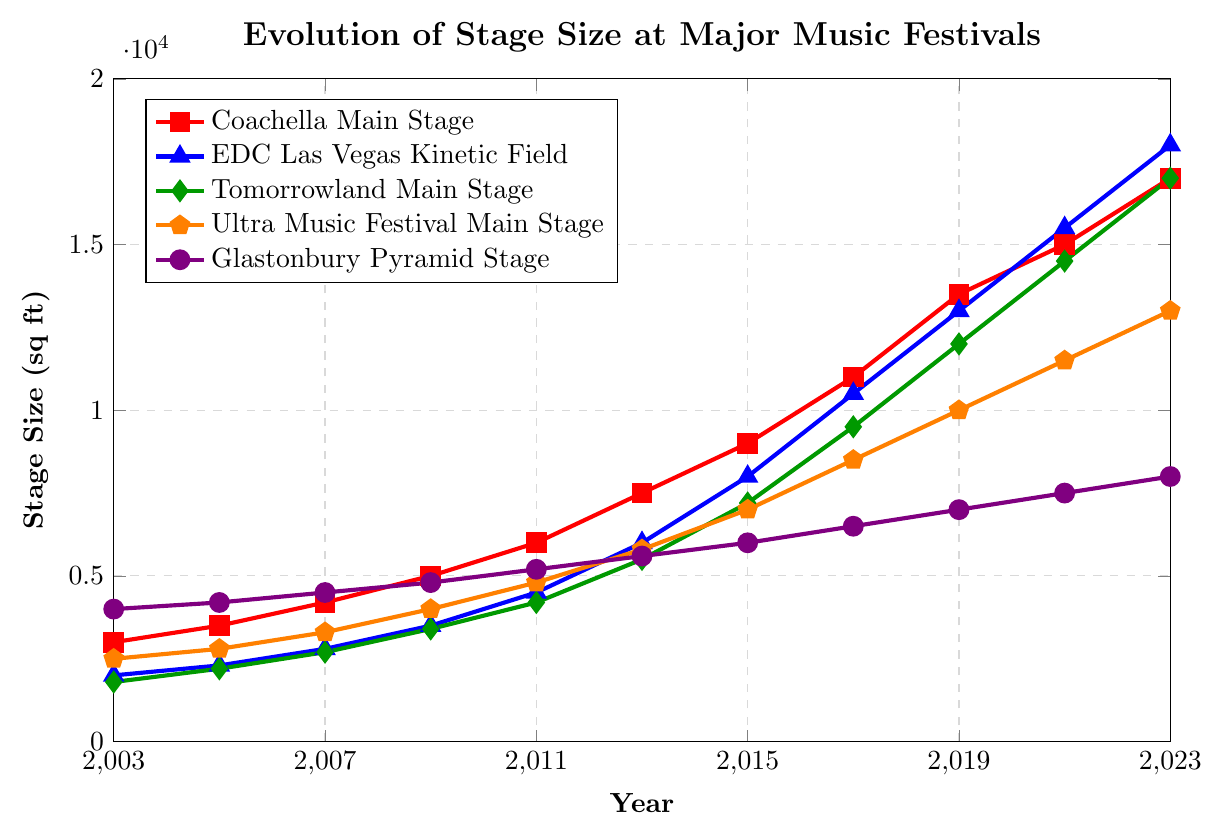What is the trend in stage size for the Coachella Main Stage over the past 20 years? The trend can be identified by observing the line corresponding to the Coachella Main Stage. The stage size for Coachella starts at 3000 sq ft in 2003 and consistently increases to 17000 sq ft by 2023.
Answer: Increasing trend Which festival had the largest stage size in 2017? To determine this, compare the stage sizes in 2017 for all festivals. The sizes are Coachella Main Stage (11000 sq ft), EDC Las Vegas Kinetic Field (10500 sq ft), Tomorrowland Main Stage (9500 sq ft), Ultra Music Festival Main Stage (8500 sq ft), Glastonbury Pyramid Stage (6500 sq ft). The largest size in 2017 is Coachella Main Stage at 11000 sq ft.
Answer: Coachella Main Stage What is the difference in stage size between EDC Las Vegas and Glastonbury Pyramid Stage in 2023? Subtract the stage size of Glastonbury Pyramid Stage (8000 sq ft) from EDC Las Vegas Kinetic Field (18000 sq ft) in 2023. The calculation is 18000 - 8000 = 10000 sq ft.
Answer: 10000 sq ft Which festival's stage size saw the most significant growth from 2003 to 2023? Calculate the difference in stage size from 2003 to 2023 for each festival. Coachella: 17000 - 3000 = 14000 sq ft, EDC Las Vegas: 18000 - 2000 = 16000 sq ft, Tomorrowland: 17000 - 1800 = 15200 sq ft, Ultra Music Festival: 13000 - 2500 = 10500 sq ft, Glastonbury: 8000 - 4000 = 4000 sq ft. The largest growth is seen in EDC Las Vegas Kinetic Field with an increase of 16000 sq ft.
Answer: EDC Las Vegas Kinetic Field How did the stage size for Tomorrowland Main Stage change between 2007 and 2013? Observe the trend for Tomorrowland Main Stage from 2007 to 2013. In 2007, the size was 2700 sq ft, and in 2013 it was 5500 sq ft. The change is 5500 - 2700 = 2800 sq ft.
Answer: Increased by 2800 sq ft Which festival stages were larger than 10000 sq ft in 2019? Identify stage sizes in 2019 and check which ones are above 10000 sq ft. The sizes are Coachella Main Stage (13500 sq ft), EDC Las Vegas Kinetic Field (13000 sq ft), Tomorrowland Main Stage (12000 sq ft), Ultra Music Festival Main Stage (10000 sq ft), Glastonbury Pyramid Stage (7000 sq ft). The stages larger than 10000 sq ft are Coachella Main Stage, EDC Las Vegas Kinetic Field, and Tomorrowland Main Stage.
Answer: Coachella Main Stage, EDC Las Vegas Kinetic Field, Tomorrowland Main Stage What is the average stage size for Ultra Music Festival Main Stage over the 20 years? Sum the stage sizes of Ultra Music Festival Main Stage from 2003 to 2023 and divide by the number of years. The sizes are 2500, 2800, 3300, 4000, 4800, 5800, 7000, 8500, 10000, 11500, 13000. Sum = 66300. There are 11 data points, so the average is 66300 / 11 ≈ 6027 sq ft.
Answer: 6027 sq ft Did any festivals have a decrease in stage size at any point over the last 20 years? Analyze the trends for each festival to see if there is any decrease at any point. All the festivals show consistent increases in stage sizes without any decreases.
Answer: No What was the total increase in stage size for the Tomorrowland Main Stage from 2003 to 2009? Determine the stage sizes in 2003 and 2009 for Tomorrowland Main Stage and calculate the difference. In 2003, the size was 1800 sq ft, and in 2009 it was 3400 sq ft. The increase is 3400 - 1800 = 1600 sq ft.
Answer: 1600 sq ft 